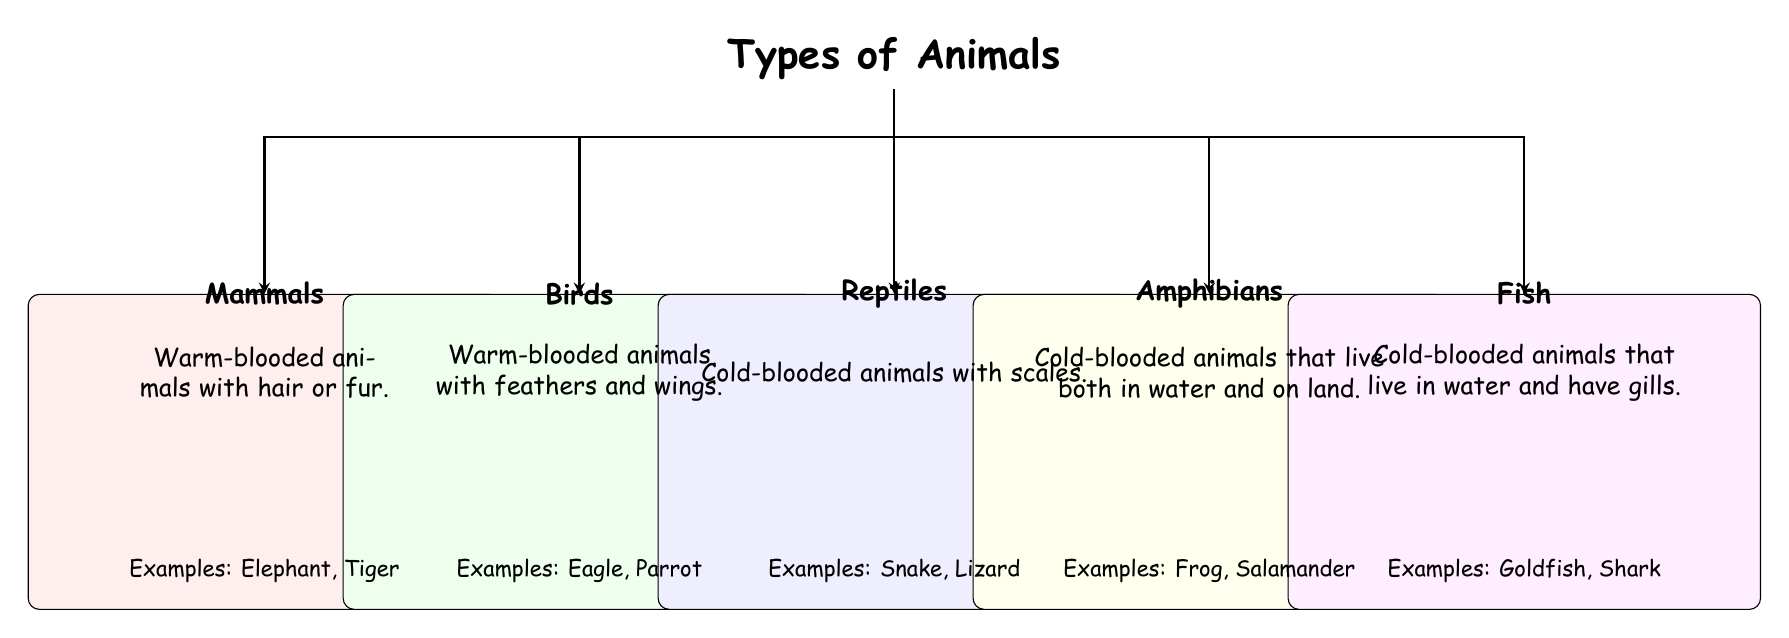What are the examples of mammals according to the diagram? The diagram states "Examples: Elephant, Tiger" under the section for Mammals, indicating specific mammals that represent this category.
Answer: Elephant, Tiger How many categories of animals are in the diagram? The diagram has five distinct categories: Mammals, Birds, Reptiles, Amphibians, and Fish, totaling five categories of animals.
Answer: 5 What type of animals are described as cold-blooded and have gills? The description for Fish states they are "Cold-blooded animals that live in water and have gills," specifically pointing out these unique features.
Answer: Fish What is the unique feature of reptiles as stated in the diagram? The diagram describes reptiles as "Cold-blooded animals with scales," which is the distinguishing characteristic listed for this group.
Answer: Scales Which two categories of animals are classified as warm-blooded? The diagram states that both Mammals and Birds are warm-blooded, indicating they share this physiological characteristic.
Answer: Mammals, Birds What do amphibians need for their life cycle according to the diagram? The description provided for Amphibians indicates that they "live both in water and on land," suggesting a need for both environments in their life cycle.
Answer: Water and land Which category contains animals with feathers? The Birds category identifies them specifically by stating they are known for having "feathers and wings," distinguishing them from other animal types.
Answer: Birds How many examples of reptiles are listed in the diagram? Under the Reptiles section, the diagram provides two examples: "Snake, Lizard," thus specifically stating the count of examples given.
Answer: 2 